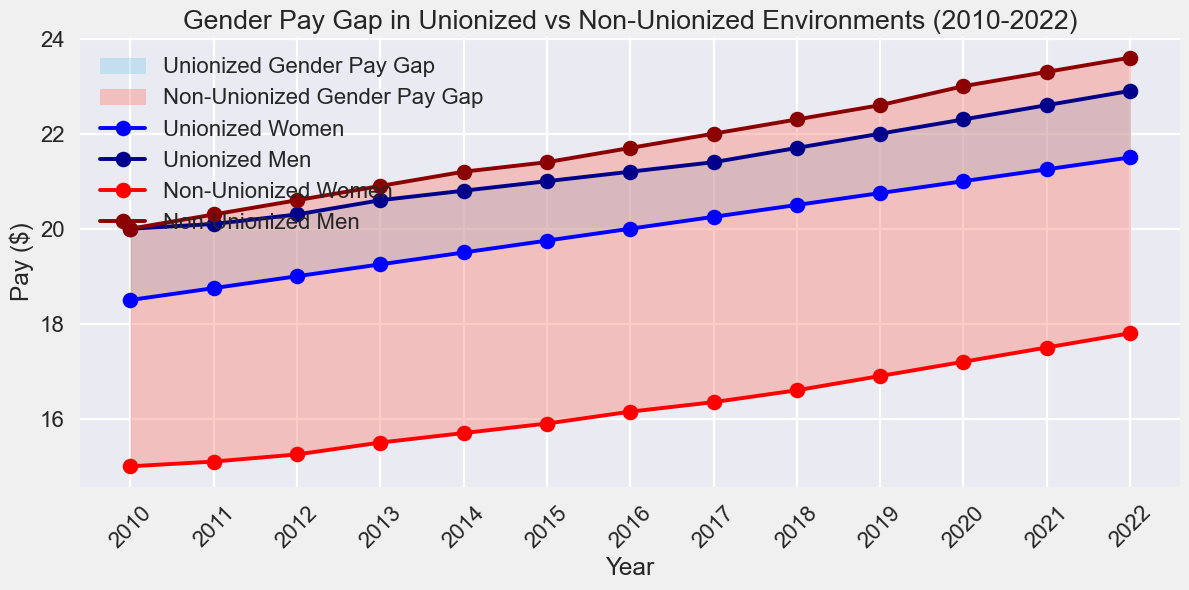How has the pay for unionized women changed from 2010 to 2022? The pay for unionized women in 2010 was $18.50, and it increased to $21.50 in 2022. By simply finding the difference between these two values, we get the pay change: $21.50 - $18.50 = $3.00.
Answer: $3.00 In which year was the pay difference between unionized women and non-unionized women the smallest? By examining the figure, we can compare the gaps year by year between unionized women and non-unionized women. The smallest difference is observed when the two curves are closest to each other.
Answer: 2010 Which group showed the highest increase in pay between 2010 and 2022? By comparing the pay increase for all four groups (unionized women, unionized men, non-unionized women, non-unionized men), we observe that non-unionized men increased from $20.00 to $23.60, which is a $3.60 increase — the largest among all groups.
Answer: Non-unionized men What is the average pay for unionized men over the years 2010 to 2022? The average can be calculated by summing the pay for all years for unionized men and then dividing by the number of years. The values are: 20.00, 20.10, 20.30, 20.60, 20.80, 21.00, 21.20, 21.40, 21.70, 22.00, 22.30, 22.60, and 22.90. The sum of these values is 257.90. Dividing by 13 years gives 257.90 / 13 ≈ 19.84.
Answer: ~19.84 How does the pay gap between unionized women and unionized men in 2022 compare to the pay gap between non-unionized women and non-unionized men in the same year? In 2022, the pay for unionized women is $21.50, and for unionized men, it is $22.90. The gap is $22.90 - $21.50 = $1.40. For non-unionized women, the pay is $17.80, and for non-unionized men, it is $23.60. The gap is $23.60 - $17.80 = $5.80. Comparing these, the gap is smaller in the unionized group: $1.40 vs $5.80.
Answer: Unionized gap is smaller In which year did the non-unionized men’s pay surpass $22.00? By analyzing the plot, we note the year where the pay line for non-unionized men crosses the $22.00 mark. It surpassed $22.00 in 2017.
Answer: 2017 